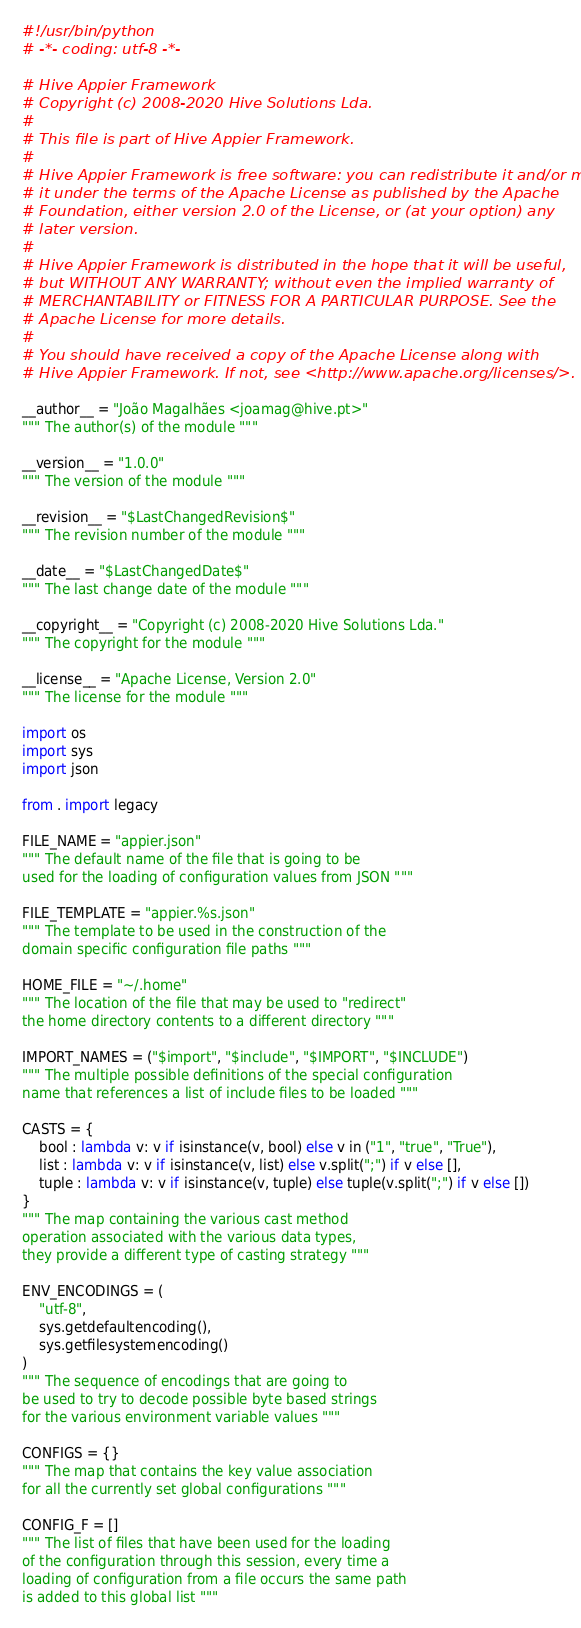Convert code to text. <code><loc_0><loc_0><loc_500><loc_500><_Python_>#!/usr/bin/python
# -*- coding: utf-8 -*-

# Hive Appier Framework
# Copyright (c) 2008-2020 Hive Solutions Lda.
#
# This file is part of Hive Appier Framework.
#
# Hive Appier Framework is free software: you can redistribute it and/or modify
# it under the terms of the Apache License as published by the Apache
# Foundation, either version 2.0 of the License, or (at your option) any
# later version.
#
# Hive Appier Framework is distributed in the hope that it will be useful,
# but WITHOUT ANY WARRANTY; without even the implied warranty of
# MERCHANTABILITY or FITNESS FOR A PARTICULAR PURPOSE. See the
# Apache License for more details.
#
# You should have received a copy of the Apache License along with
# Hive Appier Framework. If not, see <http://www.apache.org/licenses/>.

__author__ = "João Magalhães <joamag@hive.pt>"
""" The author(s) of the module """

__version__ = "1.0.0"
""" The version of the module """

__revision__ = "$LastChangedRevision$"
""" The revision number of the module """

__date__ = "$LastChangedDate$"
""" The last change date of the module """

__copyright__ = "Copyright (c) 2008-2020 Hive Solutions Lda."
""" The copyright for the module """

__license__ = "Apache License, Version 2.0"
""" The license for the module """

import os
import sys
import json

from . import legacy

FILE_NAME = "appier.json"
""" The default name of the file that is going to be
used for the loading of configuration values from JSON """

FILE_TEMPLATE = "appier.%s.json"
""" The template to be used in the construction of the
domain specific configuration file paths """

HOME_FILE = "~/.home"
""" The location of the file that may be used to "redirect"
the home directory contents to a different directory """

IMPORT_NAMES = ("$import", "$include", "$IMPORT", "$INCLUDE")
""" The multiple possible definitions of the special configuration
name that references a list of include files to be loaded """

CASTS = {
    bool : lambda v: v if isinstance(v, bool) else v in ("1", "true", "True"),
    list : lambda v: v if isinstance(v, list) else v.split(";") if v else [],
    tuple : lambda v: v if isinstance(v, tuple) else tuple(v.split(";") if v else [])
}
""" The map containing the various cast method
operation associated with the various data types,
they provide a different type of casting strategy """

ENV_ENCODINGS = (
    "utf-8",
    sys.getdefaultencoding(),
    sys.getfilesystemencoding()
)
""" The sequence of encodings that are going to
be used to try to decode possible byte based strings
for the various environment variable values """

CONFIGS = {}
""" The map that contains the key value association
for all the currently set global configurations """

CONFIG_F = []
""" The list of files that have been used for the loading
of the configuration through this session, every time a
loading of configuration from a file occurs the same path
is added to this global list """
</code> 